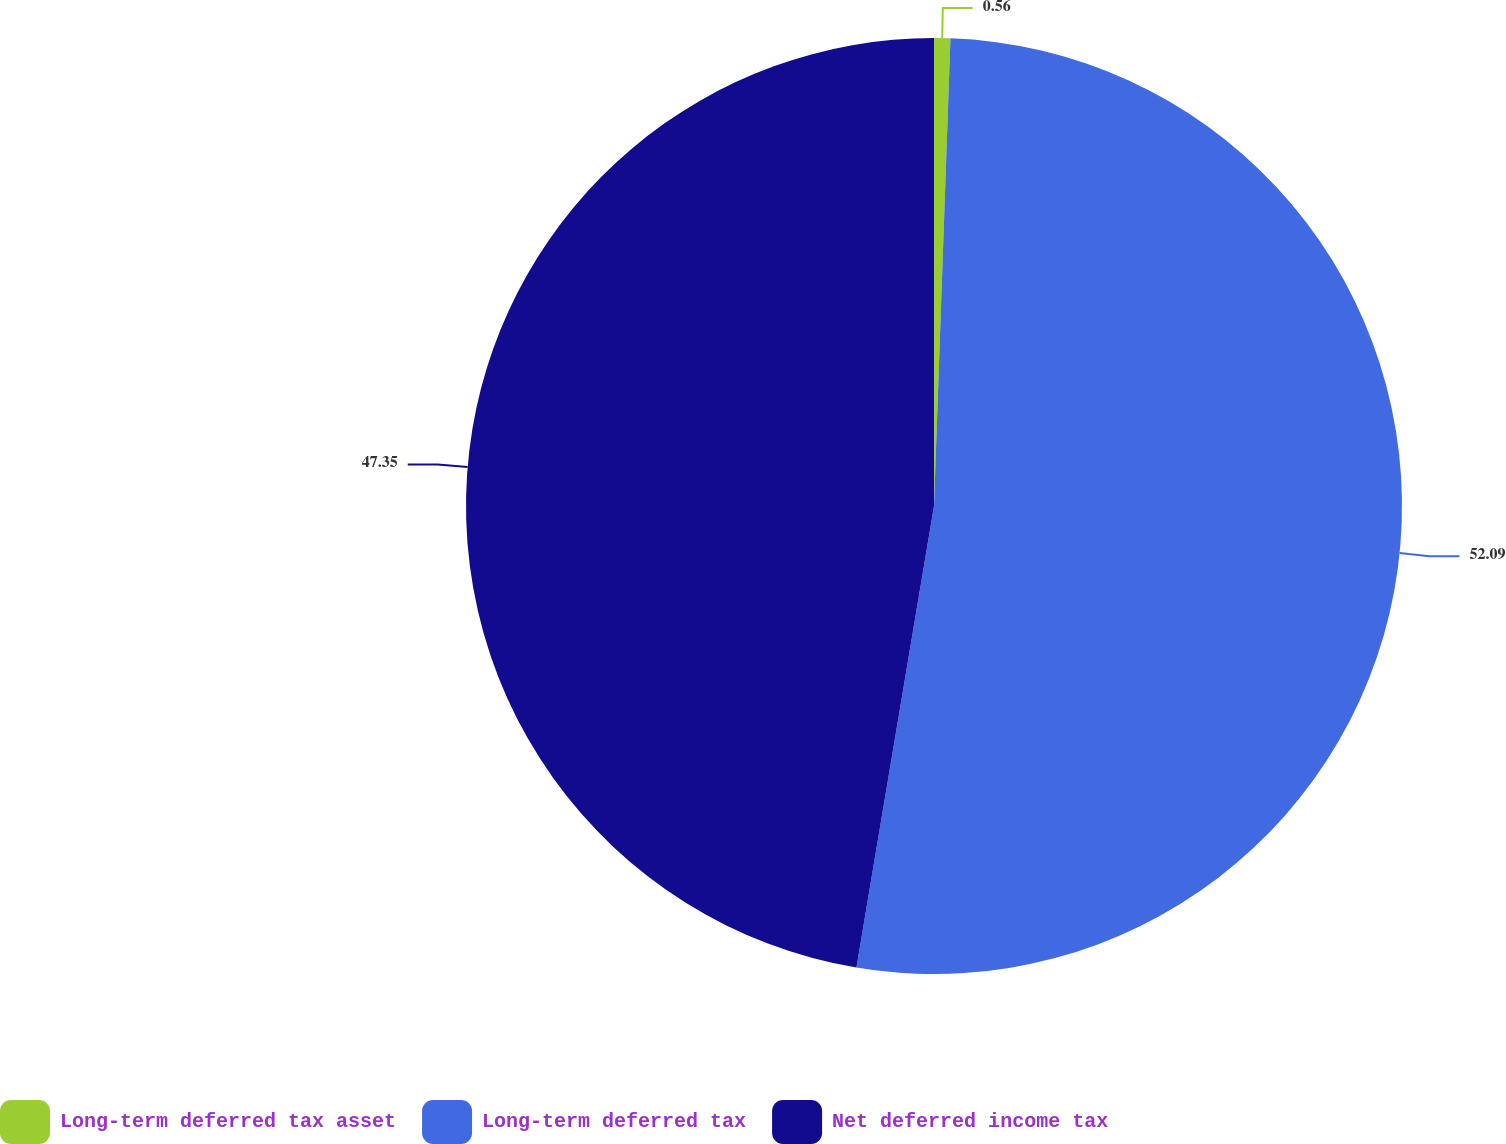Convert chart to OTSL. <chart><loc_0><loc_0><loc_500><loc_500><pie_chart><fcel>Long-term deferred tax asset<fcel>Long-term deferred tax<fcel>Net deferred income tax<nl><fcel>0.56%<fcel>52.09%<fcel>47.35%<nl></chart> 